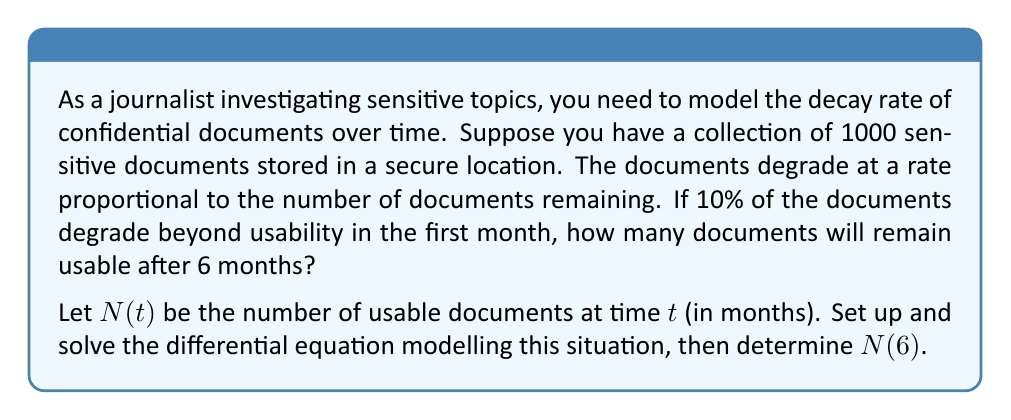Solve this math problem. 1) First, we set up the differential equation. The rate of change is proportional to the number of documents:

   $$\frac{dN}{dt} = -kN$$

   where $k$ is the decay constant.

2) We know that initially, $N(0) = 1000$.

3) After one month, 90% of the documents remain. We can use this to find $k$:

   $$N(1) = 1000 \cdot 0.9 = 900$$

4) The general solution to this differential equation is:

   $$N(t) = N_0e^{-kt}$$

   where $N_0$ is the initial number of documents.

5) Substituting the known values:

   $$900 = 1000e^{-k \cdot 1}$$

6) Solving for $k$:

   $$\begin{align}
   0.9 &= e^{-k} \\
   \ln(0.9) &= -k \\
   k &= -\ln(0.9) \approx 0.1054
   \end{align}$$

7) Now we have the complete model:

   $$N(t) = 1000e^{-0.1054t}$$

8) To find $N(6)$, we substitute $t=6$:

   $$N(6) = 1000e^{-0.1054 \cdot 6} \approx 530.88$$

9) Rounding to the nearest whole number (as we can't have fractional documents):

   $$N(6) \approx 531$$
Answer: 531 documents 